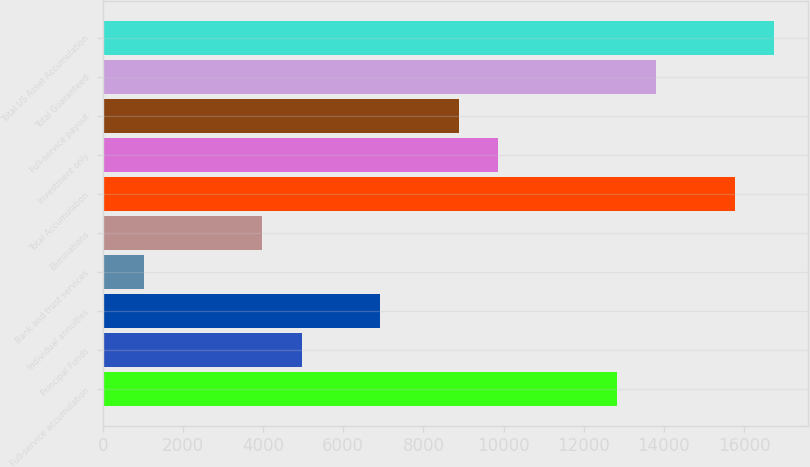Convert chart. <chart><loc_0><loc_0><loc_500><loc_500><bar_chart><fcel>Full-service accumulation<fcel>Principal Funds<fcel>Individual annuities<fcel>Bank and trust services<fcel>Eliminations<fcel>Total Accumulation<fcel>Investment only<fcel>Full-service payout<fcel>Total Guaranteed<fcel>Total US Asset Accumulation<nl><fcel>12821.8<fcel>4958.65<fcel>6924.43<fcel>1027.09<fcel>3975.76<fcel>15770.4<fcel>9873.1<fcel>8890.21<fcel>13804.7<fcel>16753.3<nl></chart> 